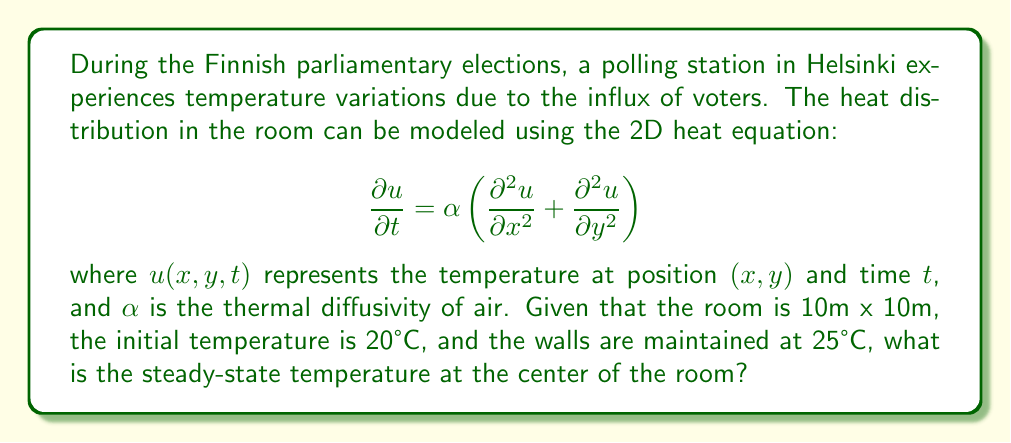Provide a solution to this math problem. To solve this problem, we need to consider the steady-state solution of the heat equation, which occurs when the temperature no longer changes with time. In this case:

1) The steady-state condition implies $\frac{\partial u}{\partial t} = 0$, so our equation becomes:

   $$0 = \alpha \left(\frac{\partial^2 u}{\partial x^2} + \frac{\partial^2 u}{\partial y^2}\right)$$

2) This is now Laplace's equation in 2D: $\nabla^2 u = 0$

3) Given the symmetry of the problem (square room with uniform boundary conditions), we can expect the solution to be symmetric.

4) For a square domain with constant boundary conditions, the steady-state solution is independent of the thermal diffusivity $\alpha$.

5) The solution to Laplace's equation in 2D with these boundary conditions is:

   $$u(x,y) = 25 - \sum_{n=1,3,5,...}^{\infty} \frac{16(25-20)}{\pi^2 n^2} \sin\left(\frac{n\pi x}{10}\right)\sin\left(\frac{n\pi y}{10}\right)$$

6) At the center of the room $(x=5, y=5)$, we have:

   $$u(5,5) = 25 - \sum_{n=1,3,5,...}^{\infty} \frac{16(25-20)}{\pi^2 n^2} \sin\left(\frac{n\pi}{2}\right)\sin\left(\frac{n\pi}{2}\right)$$

7) Simplifying:

   $$u(5,5) = 25 - \frac{16(25-20)}{\pi^2} \sum_{n=1,3,5,...}^{\infty} \frac{1}{n^2}$$

8) The sum $\sum_{n=1,3,5,...}^{\infty} \frac{1}{n^2} = \frac{\pi^2}{8}$

9) Substituting this in:

   $$u(5,5) = 25 - \frac{16(25-20)}{\pi^2} \cdot \frac{\pi^2}{8} = 25 - 2(25-20) = 25 - 10 = 15$$

Therefore, the steady-state temperature at the center of the room is 15°C.
Answer: 15°C 